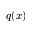<formula> <loc_0><loc_0><loc_500><loc_500>q ( x )</formula> 